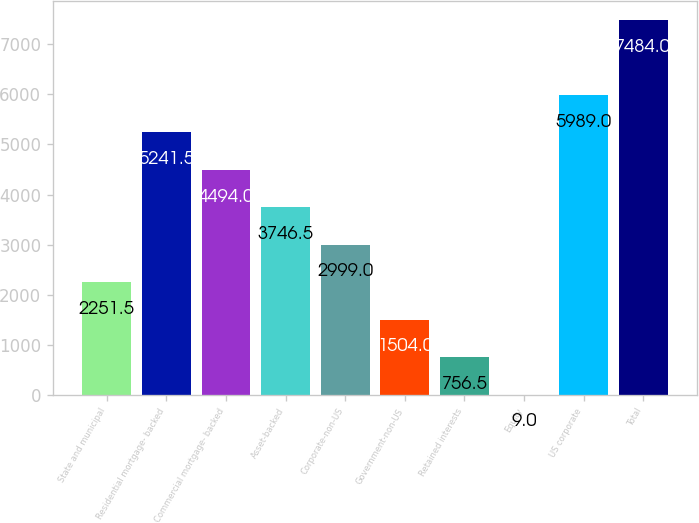Convert chart. <chart><loc_0><loc_0><loc_500><loc_500><bar_chart><fcel>State and municipal<fcel>Residential mortgage- backed<fcel>Commercial mortgage- backed<fcel>Asset-backed<fcel>Corporate-non-US<fcel>Government-non-US<fcel>Retained interests<fcel>Equity<fcel>US corporate<fcel>Total<nl><fcel>2251.5<fcel>5241.5<fcel>4494<fcel>3746.5<fcel>2999<fcel>1504<fcel>756.5<fcel>9<fcel>5989<fcel>7484<nl></chart> 